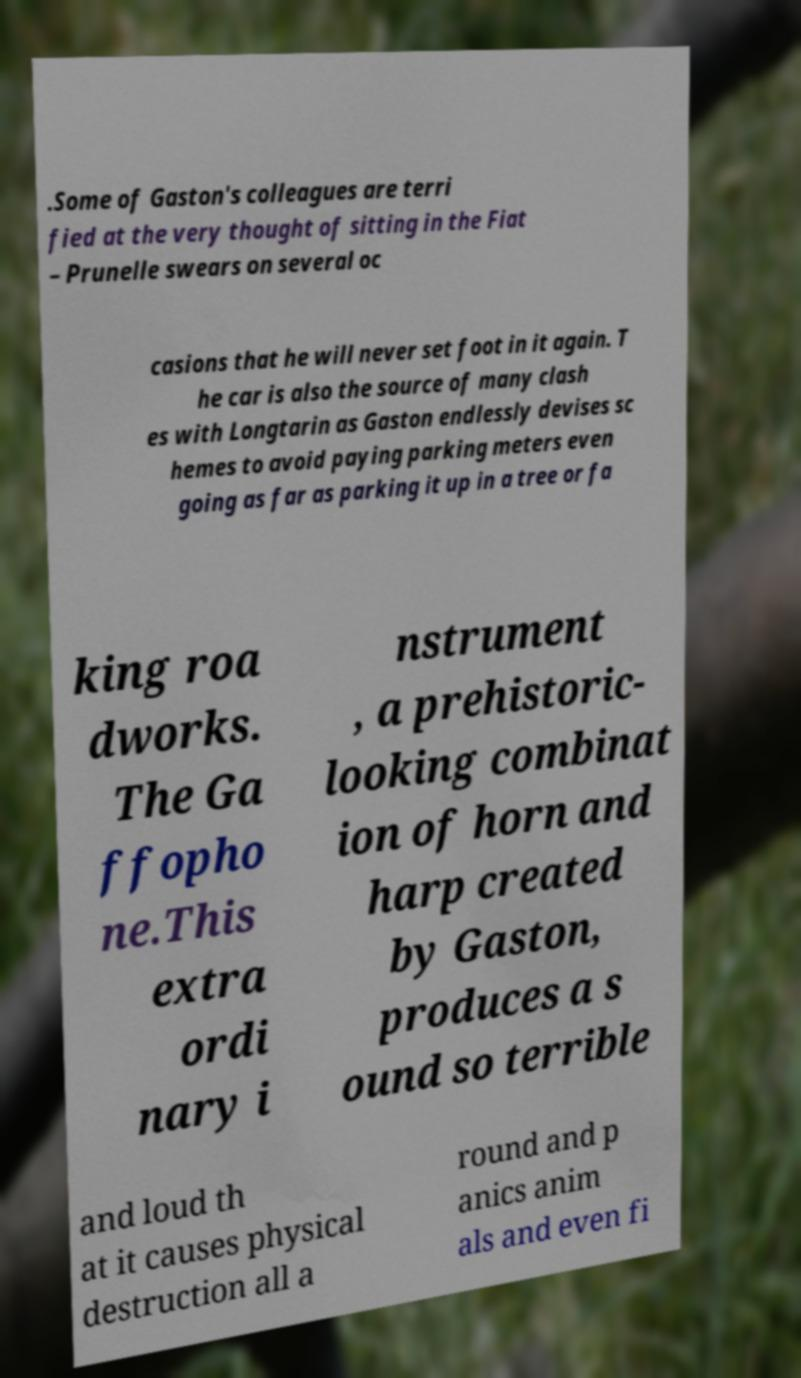Please read and relay the text visible in this image. What does it say? .Some of Gaston's colleagues are terri fied at the very thought of sitting in the Fiat – Prunelle swears on several oc casions that he will never set foot in it again. T he car is also the source of many clash es with Longtarin as Gaston endlessly devises sc hemes to avoid paying parking meters even going as far as parking it up in a tree or fa king roa dworks. The Ga ffopho ne.This extra ordi nary i nstrument , a prehistoric- looking combinat ion of horn and harp created by Gaston, produces a s ound so terrible and loud th at it causes physical destruction all a round and p anics anim als and even fi 